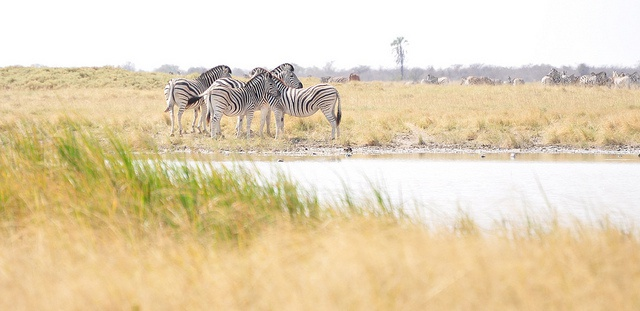Describe the objects in this image and their specific colors. I can see zebra in white, darkgray, lightgray, and tan tones, zebra in white, darkgray, gray, lightgray, and tan tones, zebra in white, darkgray, gray, lightgray, and tan tones, and zebra in white, darkgray, lightgray, tan, and gray tones in this image. 